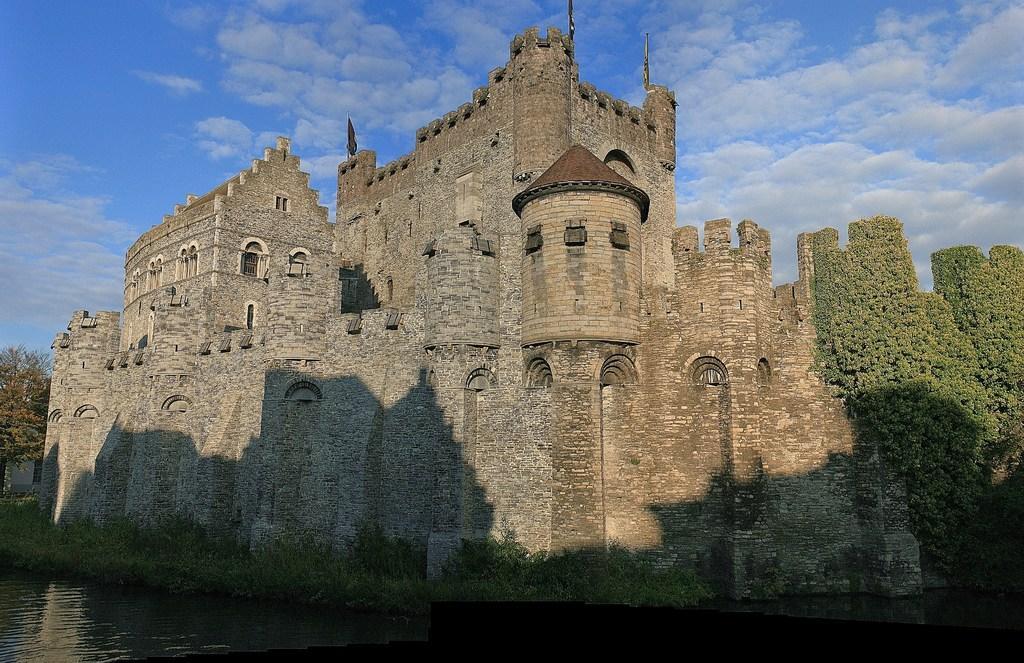How would you summarize this image in a sentence or two? In this image I can see the fort. In-front of the fort I can see the grass and the water. To the side of the fort there are many trees. In the background I can see the clouds and the sky. 